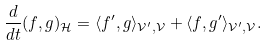<formula> <loc_0><loc_0><loc_500><loc_500>\frac { d } { d t } ( f , g ) _ { \mathcal { H } } = \langle f ^ { \prime } , g \rangle _ { \mathcal { V } ^ { \prime } , \mathcal { V } } + \langle f , g ^ { \prime } \rangle _ { \mathcal { V } ^ { \prime } , \mathcal { V } } .</formula> 